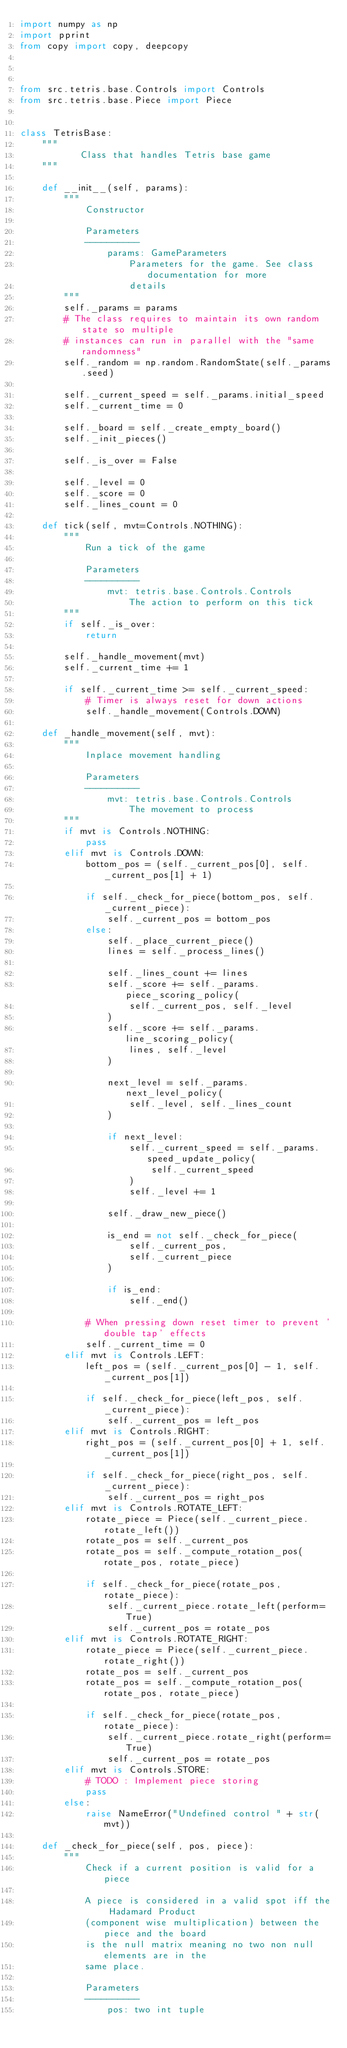<code> <loc_0><loc_0><loc_500><loc_500><_Python_>import numpy as np
import pprint
from copy import copy, deepcopy



from src.tetris.base.Controls import Controls
from src.tetris.base.Piece import Piece


class TetrisBase:
    """
           Class that handles Tetris base game
    """

    def __init__(self, params):
        """
            Constructor

            Parameters
            ----------
                params: GameParameters
                    Parameters for the game. See class documentation for more
                    details
        """
        self._params = params
        # The class requires to maintain its own random state so multiple
        # instances can run in parallel with the "same randomness"
        self._random = np.random.RandomState(self._params.seed)

        self._current_speed = self._params.initial_speed
        self._current_time = 0

        self._board = self._create_empty_board()
        self._init_pieces()

        self._is_over = False

        self._level = 0
        self._score = 0
        self._lines_count = 0

    def tick(self, mvt=Controls.NOTHING):
        """
            Run a tick of the game

            Parameters
            ----------
                mvt: tetris.base.Controls.Controls
                    The action to perform on this tick
        """
        if self._is_over:
            return      

        self._handle_movement(mvt)
        self._current_time += 1

        if self._current_time >= self._current_speed:
            # Timer is always reset for down actions
            self._handle_movement(Controls.DOWN)
        
    def _handle_movement(self, mvt):
        """
            Inplace movement handling

            Parameters
            ----------
                mvt: tetris.base.Controls.Controls
                    The movement to process
        """
        if mvt is Controls.NOTHING:
            pass
        elif mvt is Controls.DOWN:
            bottom_pos = (self._current_pos[0], self._current_pos[1] + 1)

            if self._check_for_piece(bottom_pos, self._current_piece):
                self._current_pos = bottom_pos
            else:
                self._place_current_piece()
                lines = self._process_lines()
    
                self._lines_count += lines
                self._score += self._params.piece_scoring_policy(
                    self._current_pos, self._level
                )
                self._score += self._params.line_scoring_policy(
                    lines, self._level
                )

                next_level = self._params.next_level_policy(
                    self._level, self._lines_count
                )

                if next_level:
                    self._current_speed = self._params.speed_update_policy(
                        self._current_speed
                    )
                    self._level += 1

                self._draw_new_piece()

                is_end = not self._check_for_piece(
                    self._current_pos,
                    self._current_piece
                )

                if is_end:
                    self._end()

            # When pressing down reset timer to prevent 'double tap' effects
            self._current_time = 0
        elif mvt is Controls.LEFT:
            left_pos = (self._current_pos[0] - 1, self._current_pos[1])

            if self._check_for_piece(left_pos, self._current_piece):
                self._current_pos = left_pos
        elif mvt is Controls.RIGHT:
            right_pos = (self._current_pos[0] + 1, self._current_pos[1])

            if self._check_for_piece(right_pos, self._current_piece):
                self._current_pos = right_pos
        elif mvt is Controls.ROTATE_LEFT:
            rotate_piece = Piece(self._current_piece.rotate_left())
            rotate_pos = self._current_pos
            rotate_pos = self._compute_rotation_pos(rotate_pos, rotate_piece)

            if self._check_for_piece(rotate_pos, rotate_piece):
                self._current_piece.rotate_left(perform=True)
                self._current_pos = rotate_pos
        elif mvt is Controls.ROTATE_RIGHT:
            rotate_piece = Piece(self._current_piece.rotate_right())
            rotate_pos = self._current_pos
            rotate_pos = self._compute_rotation_pos(rotate_pos, rotate_piece)

            if self._check_for_piece(rotate_pos, rotate_piece):
                self._current_piece.rotate_right(perform=True)
                self._current_pos = rotate_pos
        elif mvt is Controls.STORE:
            # TODO : Implement piece storing
            pass
        else:
            raise NameError("Undefined control " + str(mvt))

    def _check_for_piece(self, pos, piece):
        """
            Check if a current position is valid for a piece

            A piece is considered in a valid spot iff the Hadamard Product
            (component wise multiplication) between the piece and the board
            is the null matrix meaning no two non null elements are in the
            same place.

            Parameters
            ----------
                pos: two int tuple</code> 